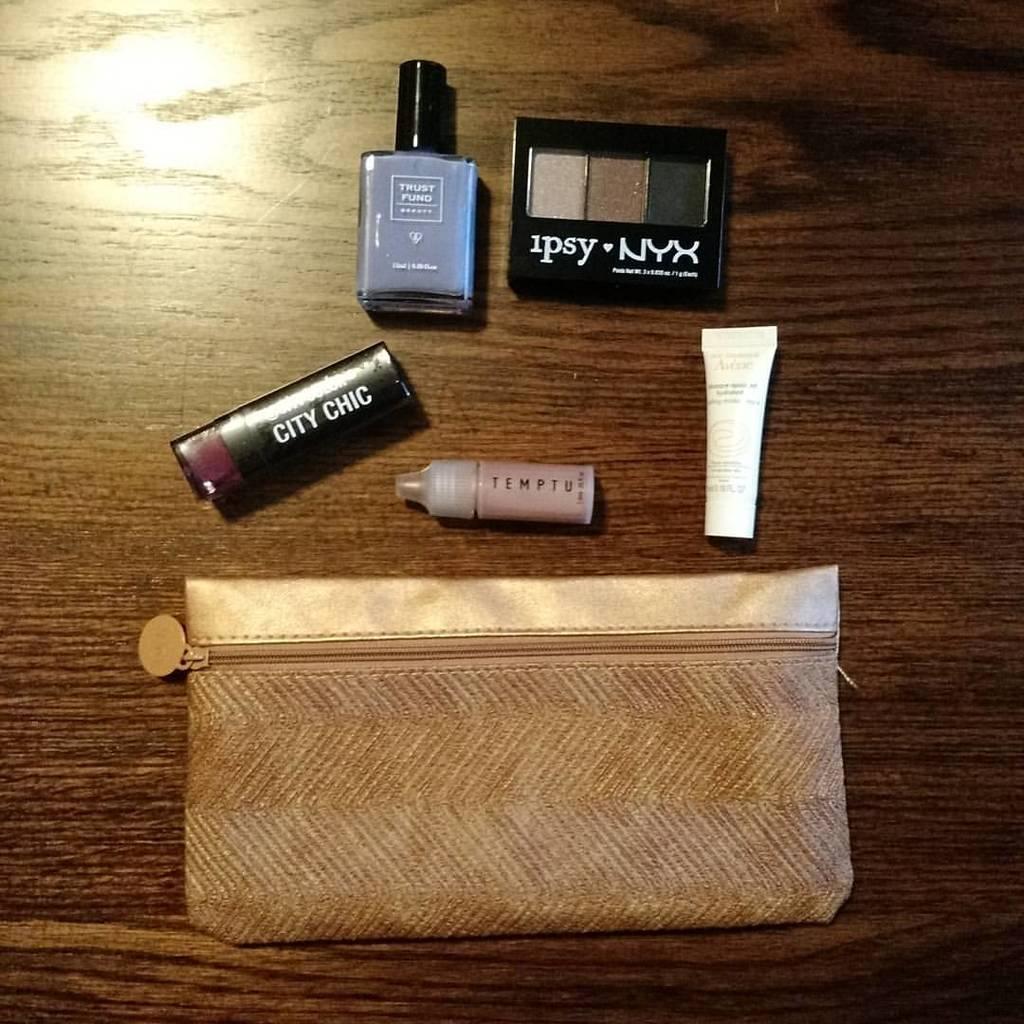What is the brand of eyeshadow?
Provide a short and direct response. Ipsy. What brand is the palet?
Offer a very short reply. Ipsy nyx. 